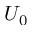Convert formula to latex. <formula><loc_0><loc_0><loc_500><loc_500>U _ { 0 }</formula> 